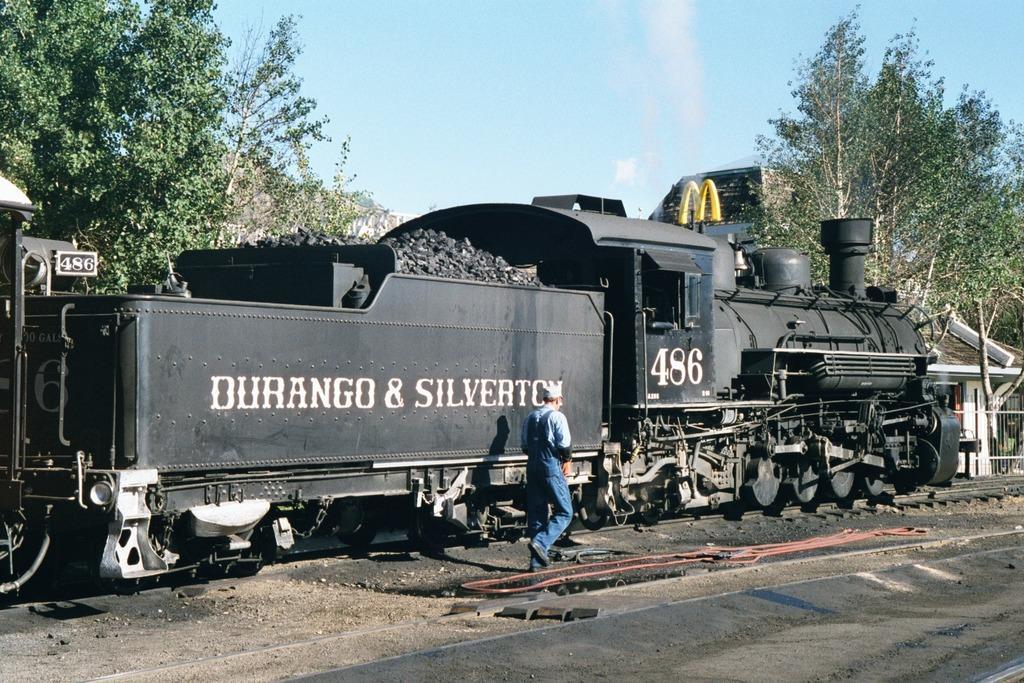Describe this image in one or two sentences. In this image, this looks like a train, which is on the rail track. I think this is the coal. Here is a person walking. These are the trees. This looks like a building. 